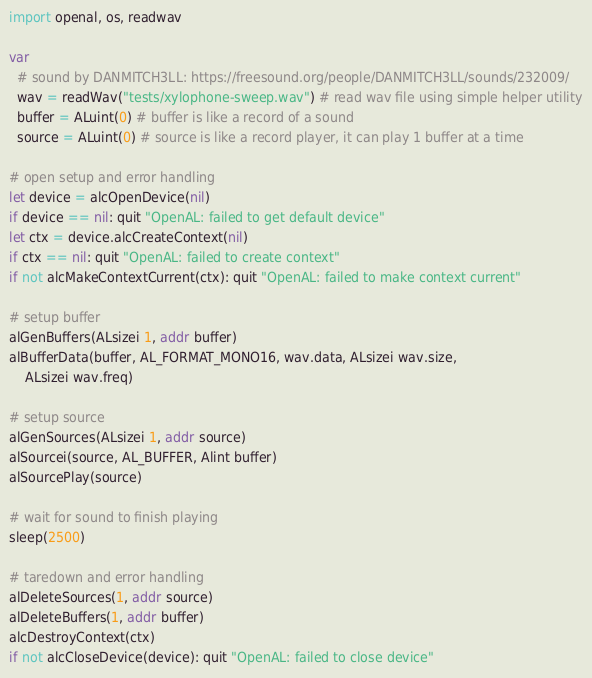<code> <loc_0><loc_0><loc_500><loc_500><_Nim_>import openal, os, readwav

var
  # sound by DANMITCH3LL: https://freesound.org/people/DANMITCH3LL/sounds/232009/
  wav = readWav("tests/xylophone-sweep.wav") # read wav file using simple helper utility
  buffer = ALuint(0) # buffer is like a record of a sound
  source = ALuint(0) # source is like a record player, it can play 1 buffer at a time

# open setup and error handling
let device = alcOpenDevice(nil)
if device == nil: quit "OpenAL: failed to get default device"
let ctx = device.alcCreateContext(nil)
if ctx == nil: quit "OpenAL: failed to create context"
if not alcMakeContextCurrent(ctx): quit "OpenAL: failed to make context current"

# setup buffer
alGenBuffers(ALsizei 1, addr buffer)
alBufferData(buffer, AL_FORMAT_MONO16, wav.data, ALsizei wav.size,
    ALsizei wav.freq)

# setup source
alGenSources(ALsizei 1, addr source)
alSourcei(source, AL_BUFFER, Alint buffer)
alSourcePlay(source)

# wait for sound to finish playing
sleep(2500)

# taredown and error handling
alDeleteSources(1, addr source)
alDeleteBuffers(1, addr buffer)
alcDestroyContext(ctx)
if not alcCloseDevice(device): quit "OpenAL: failed to close device"
</code> 